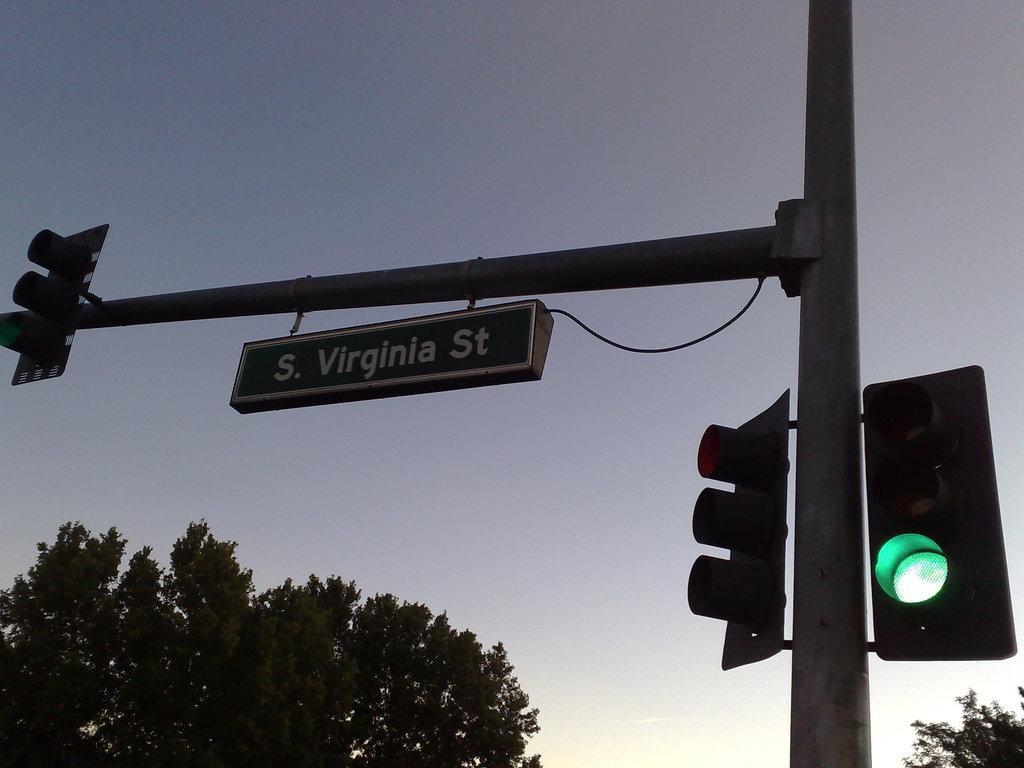Please provide a concise description of this image. In this picture we can see a name board, pole, traffic signals, trees and in the background we can see the sky. 